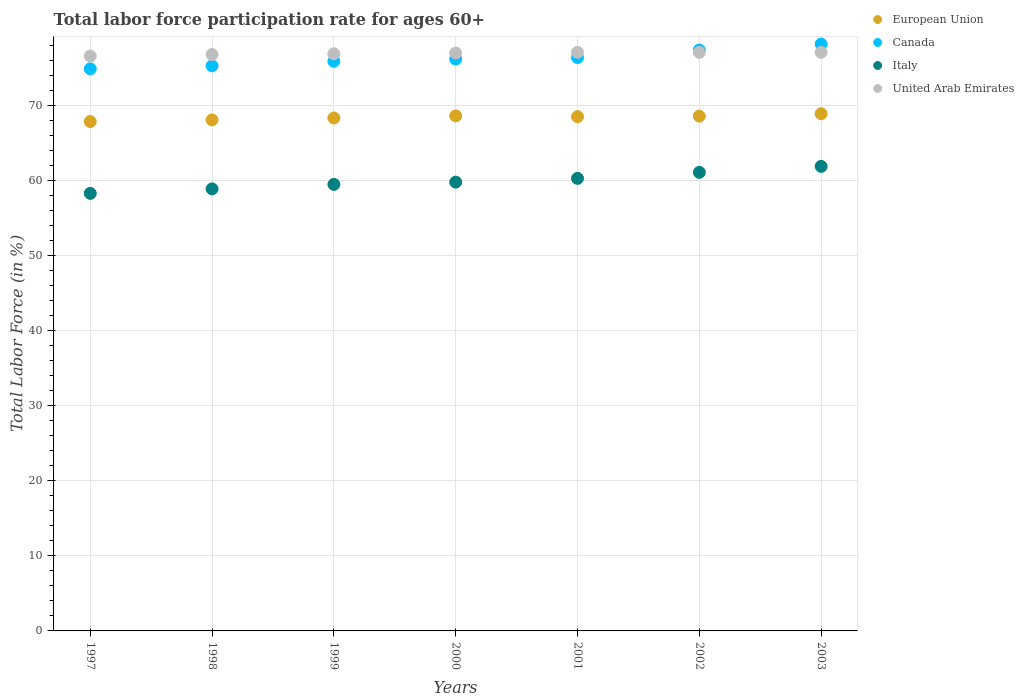Is the number of dotlines equal to the number of legend labels?
Your answer should be very brief. Yes. What is the labor force participation rate in Italy in 2001?
Make the answer very short. 60.3. Across all years, what is the maximum labor force participation rate in United Arab Emirates?
Your response must be concise. 77.1. Across all years, what is the minimum labor force participation rate in European Union?
Offer a terse response. 67.87. In which year was the labor force participation rate in Canada maximum?
Your answer should be very brief. 2003. In which year was the labor force participation rate in United Arab Emirates minimum?
Make the answer very short. 1997. What is the total labor force participation rate in Italy in the graph?
Ensure brevity in your answer.  419.8. What is the difference between the labor force participation rate in Canada in 2002 and that in 2003?
Offer a very short reply. -0.8. What is the difference between the labor force participation rate in Italy in 1999 and the labor force participation rate in European Union in 2001?
Offer a terse response. -9.02. What is the average labor force participation rate in European Union per year?
Your answer should be very brief. 68.42. In the year 2003, what is the difference between the labor force participation rate in European Union and labor force participation rate in Italy?
Offer a terse response. 7.01. In how many years, is the labor force participation rate in United Arab Emirates greater than 40 %?
Offer a very short reply. 7. What is the ratio of the labor force participation rate in United Arab Emirates in 1998 to that in 2001?
Provide a short and direct response. 1. Is the difference between the labor force participation rate in European Union in 2000 and 2003 greater than the difference between the labor force participation rate in Italy in 2000 and 2003?
Provide a short and direct response. Yes. What is the difference between the highest and the second highest labor force participation rate in United Arab Emirates?
Offer a very short reply. 0. What is the difference between the highest and the lowest labor force participation rate in European Union?
Keep it short and to the point. 1.04. Is it the case that in every year, the sum of the labor force participation rate in Italy and labor force participation rate in United Arab Emirates  is greater than the labor force participation rate in Canada?
Your response must be concise. Yes. Is the labor force participation rate in United Arab Emirates strictly greater than the labor force participation rate in Italy over the years?
Ensure brevity in your answer.  Yes. Is the labor force participation rate in Italy strictly less than the labor force participation rate in European Union over the years?
Provide a succinct answer. Yes. How many years are there in the graph?
Your answer should be compact. 7. What is the difference between two consecutive major ticks on the Y-axis?
Your answer should be very brief. 10. Are the values on the major ticks of Y-axis written in scientific E-notation?
Offer a very short reply. No. How are the legend labels stacked?
Provide a succinct answer. Vertical. What is the title of the graph?
Give a very brief answer. Total labor force participation rate for ages 60+. What is the Total Labor Force (in %) in European Union in 1997?
Your answer should be very brief. 67.87. What is the Total Labor Force (in %) in Canada in 1997?
Give a very brief answer. 74.9. What is the Total Labor Force (in %) of Italy in 1997?
Your answer should be compact. 58.3. What is the Total Labor Force (in %) in United Arab Emirates in 1997?
Provide a short and direct response. 76.6. What is the Total Labor Force (in %) of European Union in 1998?
Your answer should be very brief. 68.09. What is the Total Labor Force (in %) of Canada in 1998?
Your answer should be very brief. 75.3. What is the Total Labor Force (in %) of Italy in 1998?
Your response must be concise. 58.9. What is the Total Labor Force (in %) in United Arab Emirates in 1998?
Offer a very short reply. 76.8. What is the Total Labor Force (in %) in European Union in 1999?
Keep it short and to the point. 68.34. What is the Total Labor Force (in %) in Canada in 1999?
Give a very brief answer. 75.9. What is the Total Labor Force (in %) of Italy in 1999?
Your response must be concise. 59.5. What is the Total Labor Force (in %) in United Arab Emirates in 1999?
Ensure brevity in your answer.  76.9. What is the Total Labor Force (in %) in European Union in 2000?
Provide a succinct answer. 68.63. What is the Total Labor Force (in %) of Canada in 2000?
Offer a terse response. 76.2. What is the Total Labor Force (in %) in Italy in 2000?
Provide a short and direct response. 59.8. What is the Total Labor Force (in %) of European Union in 2001?
Ensure brevity in your answer.  68.52. What is the Total Labor Force (in %) in Canada in 2001?
Offer a very short reply. 76.4. What is the Total Labor Force (in %) in Italy in 2001?
Offer a terse response. 60.3. What is the Total Labor Force (in %) of United Arab Emirates in 2001?
Your response must be concise. 77.1. What is the Total Labor Force (in %) of European Union in 2002?
Ensure brevity in your answer.  68.59. What is the Total Labor Force (in %) of Canada in 2002?
Your response must be concise. 77.4. What is the Total Labor Force (in %) in Italy in 2002?
Give a very brief answer. 61.1. What is the Total Labor Force (in %) in United Arab Emirates in 2002?
Your answer should be very brief. 77.1. What is the Total Labor Force (in %) in European Union in 2003?
Make the answer very short. 68.91. What is the Total Labor Force (in %) in Canada in 2003?
Your response must be concise. 78.2. What is the Total Labor Force (in %) in Italy in 2003?
Give a very brief answer. 61.9. What is the Total Labor Force (in %) in United Arab Emirates in 2003?
Provide a short and direct response. 77.1. Across all years, what is the maximum Total Labor Force (in %) of European Union?
Your response must be concise. 68.91. Across all years, what is the maximum Total Labor Force (in %) of Canada?
Offer a terse response. 78.2. Across all years, what is the maximum Total Labor Force (in %) of Italy?
Provide a short and direct response. 61.9. Across all years, what is the maximum Total Labor Force (in %) of United Arab Emirates?
Your answer should be very brief. 77.1. Across all years, what is the minimum Total Labor Force (in %) in European Union?
Offer a terse response. 67.87. Across all years, what is the minimum Total Labor Force (in %) of Canada?
Your answer should be compact. 74.9. Across all years, what is the minimum Total Labor Force (in %) of Italy?
Offer a very short reply. 58.3. Across all years, what is the minimum Total Labor Force (in %) of United Arab Emirates?
Make the answer very short. 76.6. What is the total Total Labor Force (in %) of European Union in the graph?
Offer a very short reply. 478.96. What is the total Total Labor Force (in %) of Canada in the graph?
Provide a short and direct response. 534.3. What is the total Total Labor Force (in %) in Italy in the graph?
Make the answer very short. 419.8. What is the total Total Labor Force (in %) in United Arab Emirates in the graph?
Provide a succinct answer. 538.6. What is the difference between the Total Labor Force (in %) in European Union in 1997 and that in 1998?
Make the answer very short. -0.22. What is the difference between the Total Labor Force (in %) of Canada in 1997 and that in 1998?
Keep it short and to the point. -0.4. What is the difference between the Total Labor Force (in %) of Italy in 1997 and that in 1998?
Your response must be concise. -0.6. What is the difference between the Total Labor Force (in %) in United Arab Emirates in 1997 and that in 1998?
Your answer should be compact. -0.2. What is the difference between the Total Labor Force (in %) in European Union in 1997 and that in 1999?
Give a very brief answer. -0.47. What is the difference between the Total Labor Force (in %) in Canada in 1997 and that in 1999?
Make the answer very short. -1. What is the difference between the Total Labor Force (in %) of European Union in 1997 and that in 2000?
Offer a terse response. -0.76. What is the difference between the Total Labor Force (in %) in Italy in 1997 and that in 2000?
Keep it short and to the point. -1.5. What is the difference between the Total Labor Force (in %) in European Union in 1997 and that in 2001?
Your response must be concise. -0.65. What is the difference between the Total Labor Force (in %) of Canada in 1997 and that in 2001?
Offer a terse response. -1.5. What is the difference between the Total Labor Force (in %) in Italy in 1997 and that in 2001?
Keep it short and to the point. -2. What is the difference between the Total Labor Force (in %) in European Union in 1997 and that in 2002?
Your answer should be compact. -0.72. What is the difference between the Total Labor Force (in %) in Canada in 1997 and that in 2002?
Offer a terse response. -2.5. What is the difference between the Total Labor Force (in %) in Italy in 1997 and that in 2002?
Your response must be concise. -2.8. What is the difference between the Total Labor Force (in %) of United Arab Emirates in 1997 and that in 2002?
Ensure brevity in your answer.  -0.5. What is the difference between the Total Labor Force (in %) in European Union in 1997 and that in 2003?
Your answer should be very brief. -1.04. What is the difference between the Total Labor Force (in %) of Italy in 1997 and that in 2003?
Give a very brief answer. -3.6. What is the difference between the Total Labor Force (in %) in European Union in 1998 and that in 1999?
Your answer should be very brief. -0.25. What is the difference between the Total Labor Force (in %) of Canada in 1998 and that in 1999?
Offer a very short reply. -0.6. What is the difference between the Total Labor Force (in %) of Italy in 1998 and that in 1999?
Give a very brief answer. -0.6. What is the difference between the Total Labor Force (in %) of European Union in 1998 and that in 2000?
Your answer should be very brief. -0.54. What is the difference between the Total Labor Force (in %) in Italy in 1998 and that in 2000?
Provide a short and direct response. -0.9. What is the difference between the Total Labor Force (in %) of United Arab Emirates in 1998 and that in 2000?
Your response must be concise. -0.2. What is the difference between the Total Labor Force (in %) in European Union in 1998 and that in 2001?
Provide a short and direct response. -0.43. What is the difference between the Total Labor Force (in %) in United Arab Emirates in 1998 and that in 2001?
Provide a short and direct response. -0.3. What is the difference between the Total Labor Force (in %) of European Union in 1998 and that in 2002?
Your response must be concise. -0.5. What is the difference between the Total Labor Force (in %) of Canada in 1998 and that in 2002?
Ensure brevity in your answer.  -2.1. What is the difference between the Total Labor Force (in %) of United Arab Emirates in 1998 and that in 2002?
Your answer should be very brief. -0.3. What is the difference between the Total Labor Force (in %) of European Union in 1998 and that in 2003?
Provide a succinct answer. -0.82. What is the difference between the Total Labor Force (in %) in Canada in 1998 and that in 2003?
Ensure brevity in your answer.  -2.9. What is the difference between the Total Labor Force (in %) of European Union in 1999 and that in 2000?
Your answer should be compact. -0.28. What is the difference between the Total Labor Force (in %) in United Arab Emirates in 1999 and that in 2000?
Your answer should be very brief. -0.1. What is the difference between the Total Labor Force (in %) in European Union in 1999 and that in 2001?
Offer a terse response. -0.18. What is the difference between the Total Labor Force (in %) in United Arab Emirates in 1999 and that in 2001?
Provide a succinct answer. -0.2. What is the difference between the Total Labor Force (in %) in European Union in 1999 and that in 2002?
Offer a terse response. -0.24. What is the difference between the Total Labor Force (in %) of Canada in 1999 and that in 2002?
Ensure brevity in your answer.  -1.5. What is the difference between the Total Labor Force (in %) of Italy in 1999 and that in 2002?
Your response must be concise. -1.6. What is the difference between the Total Labor Force (in %) in European Union in 1999 and that in 2003?
Offer a very short reply. -0.57. What is the difference between the Total Labor Force (in %) of European Union in 2000 and that in 2001?
Offer a very short reply. 0.11. What is the difference between the Total Labor Force (in %) of Italy in 2000 and that in 2001?
Your answer should be compact. -0.5. What is the difference between the Total Labor Force (in %) of European Union in 2000 and that in 2002?
Your answer should be very brief. 0.04. What is the difference between the Total Labor Force (in %) of Canada in 2000 and that in 2002?
Keep it short and to the point. -1.2. What is the difference between the Total Labor Force (in %) of Italy in 2000 and that in 2002?
Provide a short and direct response. -1.3. What is the difference between the Total Labor Force (in %) in United Arab Emirates in 2000 and that in 2002?
Offer a terse response. -0.1. What is the difference between the Total Labor Force (in %) of European Union in 2000 and that in 2003?
Keep it short and to the point. -0.28. What is the difference between the Total Labor Force (in %) of Canada in 2000 and that in 2003?
Make the answer very short. -2. What is the difference between the Total Labor Force (in %) in United Arab Emirates in 2000 and that in 2003?
Provide a succinct answer. -0.1. What is the difference between the Total Labor Force (in %) in European Union in 2001 and that in 2002?
Your answer should be compact. -0.07. What is the difference between the Total Labor Force (in %) of Canada in 2001 and that in 2002?
Give a very brief answer. -1. What is the difference between the Total Labor Force (in %) of United Arab Emirates in 2001 and that in 2002?
Make the answer very short. 0. What is the difference between the Total Labor Force (in %) in European Union in 2001 and that in 2003?
Offer a very short reply. -0.39. What is the difference between the Total Labor Force (in %) in Canada in 2001 and that in 2003?
Provide a short and direct response. -1.8. What is the difference between the Total Labor Force (in %) of Italy in 2001 and that in 2003?
Ensure brevity in your answer.  -1.6. What is the difference between the Total Labor Force (in %) in European Union in 2002 and that in 2003?
Your answer should be compact. -0.32. What is the difference between the Total Labor Force (in %) of Canada in 2002 and that in 2003?
Offer a very short reply. -0.8. What is the difference between the Total Labor Force (in %) of Italy in 2002 and that in 2003?
Offer a very short reply. -0.8. What is the difference between the Total Labor Force (in %) in United Arab Emirates in 2002 and that in 2003?
Ensure brevity in your answer.  0. What is the difference between the Total Labor Force (in %) in European Union in 1997 and the Total Labor Force (in %) in Canada in 1998?
Your response must be concise. -7.43. What is the difference between the Total Labor Force (in %) in European Union in 1997 and the Total Labor Force (in %) in Italy in 1998?
Ensure brevity in your answer.  8.97. What is the difference between the Total Labor Force (in %) of European Union in 1997 and the Total Labor Force (in %) of United Arab Emirates in 1998?
Your answer should be very brief. -8.93. What is the difference between the Total Labor Force (in %) of Canada in 1997 and the Total Labor Force (in %) of Italy in 1998?
Offer a very short reply. 16. What is the difference between the Total Labor Force (in %) in Canada in 1997 and the Total Labor Force (in %) in United Arab Emirates in 1998?
Offer a very short reply. -1.9. What is the difference between the Total Labor Force (in %) in Italy in 1997 and the Total Labor Force (in %) in United Arab Emirates in 1998?
Offer a terse response. -18.5. What is the difference between the Total Labor Force (in %) in European Union in 1997 and the Total Labor Force (in %) in Canada in 1999?
Give a very brief answer. -8.03. What is the difference between the Total Labor Force (in %) of European Union in 1997 and the Total Labor Force (in %) of Italy in 1999?
Your answer should be very brief. 8.37. What is the difference between the Total Labor Force (in %) in European Union in 1997 and the Total Labor Force (in %) in United Arab Emirates in 1999?
Your response must be concise. -9.03. What is the difference between the Total Labor Force (in %) of Canada in 1997 and the Total Labor Force (in %) of Italy in 1999?
Your answer should be compact. 15.4. What is the difference between the Total Labor Force (in %) in Italy in 1997 and the Total Labor Force (in %) in United Arab Emirates in 1999?
Provide a succinct answer. -18.6. What is the difference between the Total Labor Force (in %) of European Union in 1997 and the Total Labor Force (in %) of Canada in 2000?
Provide a succinct answer. -8.33. What is the difference between the Total Labor Force (in %) of European Union in 1997 and the Total Labor Force (in %) of Italy in 2000?
Make the answer very short. 8.07. What is the difference between the Total Labor Force (in %) of European Union in 1997 and the Total Labor Force (in %) of United Arab Emirates in 2000?
Your answer should be compact. -9.13. What is the difference between the Total Labor Force (in %) of Canada in 1997 and the Total Labor Force (in %) of Italy in 2000?
Make the answer very short. 15.1. What is the difference between the Total Labor Force (in %) of Italy in 1997 and the Total Labor Force (in %) of United Arab Emirates in 2000?
Your response must be concise. -18.7. What is the difference between the Total Labor Force (in %) in European Union in 1997 and the Total Labor Force (in %) in Canada in 2001?
Your answer should be compact. -8.53. What is the difference between the Total Labor Force (in %) of European Union in 1997 and the Total Labor Force (in %) of Italy in 2001?
Your answer should be compact. 7.57. What is the difference between the Total Labor Force (in %) of European Union in 1997 and the Total Labor Force (in %) of United Arab Emirates in 2001?
Your answer should be very brief. -9.23. What is the difference between the Total Labor Force (in %) of Canada in 1997 and the Total Labor Force (in %) of United Arab Emirates in 2001?
Your response must be concise. -2.2. What is the difference between the Total Labor Force (in %) of Italy in 1997 and the Total Labor Force (in %) of United Arab Emirates in 2001?
Offer a very short reply. -18.8. What is the difference between the Total Labor Force (in %) in European Union in 1997 and the Total Labor Force (in %) in Canada in 2002?
Ensure brevity in your answer.  -9.53. What is the difference between the Total Labor Force (in %) in European Union in 1997 and the Total Labor Force (in %) in Italy in 2002?
Make the answer very short. 6.77. What is the difference between the Total Labor Force (in %) of European Union in 1997 and the Total Labor Force (in %) of United Arab Emirates in 2002?
Your response must be concise. -9.23. What is the difference between the Total Labor Force (in %) of Canada in 1997 and the Total Labor Force (in %) of United Arab Emirates in 2002?
Ensure brevity in your answer.  -2.2. What is the difference between the Total Labor Force (in %) of Italy in 1997 and the Total Labor Force (in %) of United Arab Emirates in 2002?
Your response must be concise. -18.8. What is the difference between the Total Labor Force (in %) in European Union in 1997 and the Total Labor Force (in %) in Canada in 2003?
Provide a succinct answer. -10.33. What is the difference between the Total Labor Force (in %) in European Union in 1997 and the Total Labor Force (in %) in Italy in 2003?
Your answer should be very brief. 5.97. What is the difference between the Total Labor Force (in %) of European Union in 1997 and the Total Labor Force (in %) of United Arab Emirates in 2003?
Ensure brevity in your answer.  -9.23. What is the difference between the Total Labor Force (in %) in Canada in 1997 and the Total Labor Force (in %) in United Arab Emirates in 2003?
Make the answer very short. -2.2. What is the difference between the Total Labor Force (in %) in Italy in 1997 and the Total Labor Force (in %) in United Arab Emirates in 2003?
Your answer should be compact. -18.8. What is the difference between the Total Labor Force (in %) in European Union in 1998 and the Total Labor Force (in %) in Canada in 1999?
Keep it short and to the point. -7.81. What is the difference between the Total Labor Force (in %) in European Union in 1998 and the Total Labor Force (in %) in Italy in 1999?
Make the answer very short. 8.59. What is the difference between the Total Labor Force (in %) of European Union in 1998 and the Total Labor Force (in %) of United Arab Emirates in 1999?
Ensure brevity in your answer.  -8.81. What is the difference between the Total Labor Force (in %) in Canada in 1998 and the Total Labor Force (in %) in Italy in 1999?
Your response must be concise. 15.8. What is the difference between the Total Labor Force (in %) of Italy in 1998 and the Total Labor Force (in %) of United Arab Emirates in 1999?
Your answer should be compact. -18. What is the difference between the Total Labor Force (in %) in European Union in 1998 and the Total Labor Force (in %) in Canada in 2000?
Provide a succinct answer. -8.11. What is the difference between the Total Labor Force (in %) in European Union in 1998 and the Total Labor Force (in %) in Italy in 2000?
Your answer should be very brief. 8.29. What is the difference between the Total Labor Force (in %) in European Union in 1998 and the Total Labor Force (in %) in United Arab Emirates in 2000?
Offer a very short reply. -8.91. What is the difference between the Total Labor Force (in %) of Italy in 1998 and the Total Labor Force (in %) of United Arab Emirates in 2000?
Make the answer very short. -18.1. What is the difference between the Total Labor Force (in %) in European Union in 1998 and the Total Labor Force (in %) in Canada in 2001?
Offer a terse response. -8.31. What is the difference between the Total Labor Force (in %) in European Union in 1998 and the Total Labor Force (in %) in Italy in 2001?
Your response must be concise. 7.79. What is the difference between the Total Labor Force (in %) of European Union in 1998 and the Total Labor Force (in %) of United Arab Emirates in 2001?
Ensure brevity in your answer.  -9.01. What is the difference between the Total Labor Force (in %) of Canada in 1998 and the Total Labor Force (in %) of Italy in 2001?
Your answer should be very brief. 15. What is the difference between the Total Labor Force (in %) in Canada in 1998 and the Total Labor Force (in %) in United Arab Emirates in 2001?
Offer a terse response. -1.8. What is the difference between the Total Labor Force (in %) of Italy in 1998 and the Total Labor Force (in %) of United Arab Emirates in 2001?
Your answer should be very brief. -18.2. What is the difference between the Total Labor Force (in %) in European Union in 1998 and the Total Labor Force (in %) in Canada in 2002?
Your answer should be compact. -9.31. What is the difference between the Total Labor Force (in %) in European Union in 1998 and the Total Labor Force (in %) in Italy in 2002?
Keep it short and to the point. 6.99. What is the difference between the Total Labor Force (in %) in European Union in 1998 and the Total Labor Force (in %) in United Arab Emirates in 2002?
Keep it short and to the point. -9.01. What is the difference between the Total Labor Force (in %) in Canada in 1998 and the Total Labor Force (in %) in United Arab Emirates in 2002?
Ensure brevity in your answer.  -1.8. What is the difference between the Total Labor Force (in %) of Italy in 1998 and the Total Labor Force (in %) of United Arab Emirates in 2002?
Give a very brief answer. -18.2. What is the difference between the Total Labor Force (in %) in European Union in 1998 and the Total Labor Force (in %) in Canada in 2003?
Keep it short and to the point. -10.11. What is the difference between the Total Labor Force (in %) of European Union in 1998 and the Total Labor Force (in %) of Italy in 2003?
Your answer should be very brief. 6.19. What is the difference between the Total Labor Force (in %) of European Union in 1998 and the Total Labor Force (in %) of United Arab Emirates in 2003?
Provide a short and direct response. -9.01. What is the difference between the Total Labor Force (in %) in Italy in 1998 and the Total Labor Force (in %) in United Arab Emirates in 2003?
Your answer should be very brief. -18.2. What is the difference between the Total Labor Force (in %) of European Union in 1999 and the Total Labor Force (in %) of Canada in 2000?
Your answer should be compact. -7.86. What is the difference between the Total Labor Force (in %) of European Union in 1999 and the Total Labor Force (in %) of Italy in 2000?
Ensure brevity in your answer.  8.54. What is the difference between the Total Labor Force (in %) of European Union in 1999 and the Total Labor Force (in %) of United Arab Emirates in 2000?
Keep it short and to the point. -8.66. What is the difference between the Total Labor Force (in %) of Canada in 1999 and the Total Labor Force (in %) of Italy in 2000?
Make the answer very short. 16.1. What is the difference between the Total Labor Force (in %) of Italy in 1999 and the Total Labor Force (in %) of United Arab Emirates in 2000?
Your response must be concise. -17.5. What is the difference between the Total Labor Force (in %) of European Union in 1999 and the Total Labor Force (in %) of Canada in 2001?
Offer a terse response. -8.06. What is the difference between the Total Labor Force (in %) in European Union in 1999 and the Total Labor Force (in %) in Italy in 2001?
Provide a succinct answer. 8.04. What is the difference between the Total Labor Force (in %) of European Union in 1999 and the Total Labor Force (in %) of United Arab Emirates in 2001?
Offer a terse response. -8.76. What is the difference between the Total Labor Force (in %) in Canada in 1999 and the Total Labor Force (in %) in United Arab Emirates in 2001?
Provide a succinct answer. -1.2. What is the difference between the Total Labor Force (in %) in Italy in 1999 and the Total Labor Force (in %) in United Arab Emirates in 2001?
Give a very brief answer. -17.6. What is the difference between the Total Labor Force (in %) of European Union in 1999 and the Total Labor Force (in %) of Canada in 2002?
Your answer should be compact. -9.06. What is the difference between the Total Labor Force (in %) in European Union in 1999 and the Total Labor Force (in %) in Italy in 2002?
Your answer should be very brief. 7.24. What is the difference between the Total Labor Force (in %) of European Union in 1999 and the Total Labor Force (in %) of United Arab Emirates in 2002?
Your response must be concise. -8.76. What is the difference between the Total Labor Force (in %) in Canada in 1999 and the Total Labor Force (in %) in Italy in 2002?
Offer a very short reply. 14.8. What is the difference between the Total Labor Force (in %) in Italy in 1999 and the Total Labor Force (in %) in United Arab Emirates in 2002?
Your response must be concise. -17.6. What is the difference between the Total Labor Force (in %) of European Union in 1999 and the Total Labor Force (in %) of Canada in 2003?
Keep it short and to the point. -9.86. What is the difference between the Total Labor Force (in %) of European Union in 1999 and the Total Labor Force (in %) of Italy in 2003?
Offer a terse response. 6.44. What is the difference between the Total Labor Force (in %) in European Union in 1999 and the Total Labor Force (in %) in United Arab Emirates in 2003?
Your response must be concise. -8.76. What is the difference between the Total Labor Force (in %) of Canada in 1999 and the Total Labor Force (in %) of Italy in 2003?
Your answer should be compact. 14. What is the difference between the Total Labor Force (in %) in Canada in 1999 and the Total Labor Force (in %) in United Arab Emirates in 2003?
Ensure brevity in your answer.  -1.2. What is the difference between the Total Labor Force (in %) in Italy in 1999 and the Total Labor Force (in %) in United Arab Emirates in 2003?
Offer a terse response. -17.6. What is the difference between the Total Labor Force (in %) of European Union in 2000 and the Total Labor Force (in %) of Canada in 2001?
Provide a short and direct response. -7.77. What is the difference between the Total Labor Force (in %) in European Union in 2000 and the Total Labor Force (in %) in Italy in 2001?
Provide a short and direct response. 8.33. What is the difference between the Total Labor Force (in %) of European Union in 2000 and the Total Labor Force (in %) of United Arab Emirates in 2001?
Offer a terse response. -8.47. What is the difference between the Total Labor Force (in %) in Canada in 2000 and the Total Labor Force (in %) in United Arab Emirates in 2001?
Your answer should be very brief. -0.9. What is the difference between the Total Labor Force (in %) in Italy in 2000 and the Total Labor Force (in %) in United Arab Emirates in 2001?
Give a very brief answer. -17.3. What is the difference between the Total Labor Force (in %) of European Union in 2000 and the Total Labor Force (in %) of Canada in 2002?
Your answer should be compact. -8.77. What is the difference between the Total Labor Force (in %) of European Union in 2000 and the Total Labor Force (in %) of Italy in 2002?
Your answer should be very brief. 7.53. What is the difference between the Total Labor Force (in %) in European Union in 2000 and the Total Labor Force (in %) in United Arab Emirates in 2002?
Provide a succinct answer. -8.47. What is the difference between the Total Labor Force (in %) in Canada in 2000 and the Total Labor Force (in %) in United Arab Emirates in 2002?
Your answer should be compact. -0.9. What is the difference between the Total Labor Force (in %) in Italy in 2000 and the Total Labor Force (in %) in United Arab Emirates in 2002?
Provide a short and direct response. -17.3. What is the difference between the Total Labor Force (in %) of European Union in 2000 and the Total Labor Force (in %) of Canada in 2003?
Keep it short and to the point. -9.57. What is the difference between the Total Labor Force (in %) in European Union in 2000 and the Total Labor Force (in %) in Italy in 2003?
Ensure brevity in your answer.  6.73. What is the difference between the Total Labor Force (in %) in European Union in 2000 and the Total Labor Force (in %) in United Arab Emirates in 2003?
Your answer should be very brief. -8.47. What is the difference between the Total Labor Force (in %) of Italy in 2000 and the Total Labor Force (in %) of United Arab Emirates in 2003?
Your response must be concise. -17.3. What is the difference between the Total Labor Force (in %) in European Union in 2001 and the Total Labor Force (in %) in Canada in 2002?
Ensure brevity in your answer.  -8.88. What is the difference between the Total Labor Force (in %) of European Union in 2001 and the Total Labor Force (in %) of Italy in 2002?
Make the answer very short. 7.42. What is the difference between the Total Labor Force (in %) of European Union in 2001 and the Total Labor Force (in %) of United Arab Emirates in 2002?
Provide a short and direct response. -8.58. What is the difference between the Total Labor Force (in %) in Canada in 2001 and the Total Labor Force (in %) in Italy in 2002?
Your response must be concise. 15.3. What is the difference between the Total Labor Force (in %) of Italy in 2001 and the Total Labor Force (in %) of United Arab Emirates in 2002?
Your response must be concise. -16.8. What is the difference between the Total Labor Force (in %) in European Union in 2001 and the Total Labor Force (in %) in Canada in 2003?
Offer a terse response. -9.68. What is the difference between the Total Labor Force (in %) of European Union in 2001 and the Total Labor Force (in %) of Italy in 2003?
Keep it short and to the point. 6.62. What is the difference between the Total Labor Force (in %) in European Union in 2001 and the Total Labor Force (in %) in United Arab Emirates in 2003?
Provide a short and direct response. -8.58. What is the difference between the Total Labor Force (in %) in Canada in 2001 and the Total Labor Force (in %) in Italy in 2003?
Make the answer very short. 14.5. What is the difference between the Total Labor Force (in %) of Canada in 2001 and the Total Labor Force (in %) of United Arab Emirates in 2003?
Your response must be concise. -0.7. What is the difference between the Total Labor Force (in %) in Italy in 2001 and the Total Labor Force (in %) in United Arab Emirates in 2003?
Your response must be concise. -16.8. What is the difference between the Total Labor Force (in %) of European Union in 2002 and the Total Labor Force (in %) of Canada in 2003?
Keep it short and to the point. -9.61. What is the difference between the Total Labor Force (in %) of European Union in 2002 and the Total Labor Force (in %) of Italy in 2003?
Ensure brevity in your answer.  6.69. What is the difference between the Total Labor Force (in %) in European Union in 2002 and the Total Labor Force (in %) in United Arab Emirates in 2003?
Your answer should be compact. -8.51. What is the difference between the Total Labor Force (in %) in Canada in 2002 and the Total Labor Force (in %) in United Arab Emirates in 2003?
Offer a very short reply. 0.3. What is the average Total Labor Force (in %) in European Union per year?
Keep it short and to the point. 68.42. What is the average Total Labor Force (in %) of Canada per year?
Keep it short and to the point. 76.33. What is the average Total Labor Force (in %) in Italy per year?
Your answer should be very brief. 59.97. What is the average Total Labor Force (in %) of United Arab Emirates per year?
Your answer should be compact. 76.94. In the year 1997, what is the difference between the Total Labor Force (in %) of European Union and Total Labor Force (in %) of Canada?
Your response must be concise. -7.03. In the year 1997, what is the difference between the Total Labor Force (in %) of European Union and Total Labor Force (in %) of Italy?
Give a very brief answer. 9.57. In the year 1997, what is the difference between the Total Labor Force (in %) in European Union and Total Labor Force (in %) in United Arab Emirates?
Provide a succinct answer. -8.73. In the year 1997, what is the difference between the Total Labor Force (in %) in Canada and Total Labor Force (in %) in United Arab Emirates?
Offer a terse response. -1.7. In the year 1997, what is the difference between the Total Labor Force (in %) in Italy and Total Labor Force (in %) in United Arab Emirates?
Offer a terse response. -18.3. In the year 1998, what is the difference between the Total Labor Force (in %) of European Union and Total Labor Force (in %) of Canada?
Your answer should be very brief. -7.21. In the year 1998, what is the difference between the Total Labor Force (in %) of European Union and Total Labor Force (in %) of Italy?
Give a very brief answer. 9.19. In the year 1998, what is the difference between the Total Labor Force (in %) of European Union and Total Labor Force (in %) of United Arab Emirates?
Provide a short and direct response. -8.71. In the year 1998, what is the difference between the Total Labor Force (in %) of Canada and Total Labor Force (in %) of Italy?
Make the answer very short. 16.4. In the year 1998, what is the difference between the Total Labor Force (in %) of Canada and Total Labor Force (in %) of United Arab Emirates?
Your answer should be very brief. -1.5. In the year 1998, what is the difference between the Total Labor Force (in %) in Italy and Total Labor Force (in %) in United Arab Emirates?
Your answer should be compact. -17.9. In the year 1999, what is the difference between the Total Labor Force (in %) in European Union and Total Labor Force (in %) in Canada?
Your response must be concise. -7.56. In the year 1999, what is the difference between the Total Labor Force (in %) of European Union and Total Labor Force (in %) of Italy?
Your response must be concise. 8.84. In the year 1999, what is the difference between the Total Labor Force (in %) in European Union and Total Labor Force (in %) in United Arab Emirates?
Ensure brevity in your answer.  -8.56. In the year 1999, what is the difference between the Total Labor Force (in %) in Canada and Total Labor Force (in %) in Italy?
Offer a very short reply. 16.4. In the year 1999, what is the difference between the Total Labor Force (in %) in Italy and Total Labor Force (in %) in United Arab Emirates?
Offer a terse response. -17.4. In the year 2000, what is the difference between the Total Labor Force (in %) of European Union and Total Labor Force (in %) of Canada?
Offer a very short reply. -7.57. In the year 2000, what is the difference between the Total Labor Force (in %) in European Union and Total Labor Force (in %) in Italy?
Provide a succinct answer. 8.83. In the year 2000, what is the difference between the Total Labor Force (in %) of European Union and Total Labor Force (in %) of United Arab Emirates?
Ensure brevity in your answer.  -8.37. In the year 2000, what is the difference between the Total Labor Force (in %) in Italy and Total Labor Force (in %) in United Arab Emirates?
Offer a terse response. -17.2. In the year 2001, what is the difference between the Total Labor Force (in %) in European Union and Total Labor Force (in %) in Canada?
Your response must be concise. -7.88. In the year 2001, what is the difference between the Total Labor Force (in %) in European Union and Total Labor Force (in %) in Italy?
Your answer should be compact. 8.22. In the year 2001, what is the difference between the Total Labor Force (in %) of European Union and Total Labor Force (in %) of United Arab Emirates?
Ensure brevity in your answer.  -8.58. In the year 2001, what is the difference between the Total Labor Force (in %) in Canada and Total Labor Force (in %) in United Arab Emirates?
Make the answer very short. -0.7. In the year 2001, what is the difference between the Total Labor Force (in %) in Italy and Total Labor Force (in %) in United Arab Emirates?
Your response must be concise. -16.8. In the year 2002, what is the difference between the Total Labor Force (in %) in European Union and Total Labor Force (in %) in Canada?
Make the answer very short. -8.81. In the year 2002, what is the difference between the Total Labor Force (in %) in European Union and Total Labor Force (in %) in Italy?
Offer a terse response. 7.49. In the year 2002, what is the difference between the Total Labor Force (in %) of European Union and Total Labor Force (in %) of United Arab Emirates?
Provide a succinct answer. -8.51. In the year 2002, what is the difference between the Total Labor Force (in %) in Canada and Total Labor Force (in %) in United Arab Emirates?
Ensure brevity in your answer.  0.3. In the year 2003, what is the difference between the Total Labor Force (in %) of European Union and Total Labor Force (in %) of Canada?
Provide a short and direct response. -9.29. In the year 2003, what is the difference between the Total Labor Force (in %) in European Union and Total Labor Force (in %) in Italy?
Provide a succinct answer. 7.01. In the year 2003, what is the difference between the Total Labor Force (in %) of European Union and Total Labor Force (in %) of United Arab Emirates?
Ensure brevity in your answer.  -8.19. In the year 2003, what is the difference between the Total Labor Force (in %) in Canada and Total Labor Force (in %) in United Arab Emirates?
Ensure brevity in your answer.  1.1. In the year 2003, what is the difference between the Total Labor Force (in %) in Italy and Total Labor Force (in %) in United Arab Emirates?
Make the answer very short. -15.2. What is the ratio of the Total Labor Force (in %) of Canada in 1997 to that in 1998?
Your answer should be very brief. 0.99. What is the ratio of the Total Labor Force (in %) in Italy in 1997 to that in 1998?
Your answer should be very brief. 0.99. What is the ratio of the Total Labor Force (in %) in European Union in 1997 to that in 1999?
Provide a short and direct response. 0.99. What is the ratio of the Total Labor Force (in %) in Italy in 1997 to that in 1999?
Keep it short and to the point. 0.98. What is the ratio of the Total Labor Force (in %) in United Arab Emirates in 1997 to that in 1999?
Your answer should be compact. 1. What is the ratio of the Total Labor Force (in %) of European Union in 1997 to that in 2000?
Make the answer very short. 0.99. What is the ratio of the Total Labor Force (in %) in Canada in 1997 to that in 2000?
Ensure brevity in your answer.  0.98. What is the ratio of the Total Labor Force (in %) in Italy in 1997 to that in 2000?
Provide a short and direct response. 0.97. What is the ratio of the Total Labor Force (in %) of Canada in 1997 to that in 2001?
Give a very brief answer. 0.98. What is the ratio of the Total Labor Force (in %) in Italy in 1997 to that in 2001?
Make the answer very short. 0.97. What is the ratio of the Total Labor Force (in %) in Italy in 1997 to that in 2002?
Your response must be concise. 0.95. What is the ratio of the Total Labor Force (in %) in European Union in 1997 to that in 2003?
Your answer should be compact. 0.98. What is the ratio of the Total Labor Force (in %) of Canada in 1997 to that in 2003?
Make the answer very short. 0.96. What is the ratio of the Total Labor Force (in %) in Italy in 1997 to that in 2003?
Offer a very short reply. 0.94. What is the ratio of the Total Labor Force (in %) in United Arab Emirates in 1997 to that in 2003?
Your answer should be very brief. 0.99. What is the ratio of the Total Labor Force (in %) of Canada in 1998 to that in 1999?
Offer a very short reply. 0.99. What is the ratio of the Total Labor Force (in %) of Canada in 1998 to that in 2000?
Offer a very short reply. 0.99. What is the ratio of the Total Labor Force (in %) of Italy in 1998 to that in 2000?
Make the answer very short. 0.98. What is the ratio of the Total Labor Force (in %) in United Arab Emirates in 1998 to that in 2000?
Make the answer very short. 1. What is the ratio of the Total Labor Force (in %) of Canada in 1998 to that in 2001?
Offer a terse response. 0.99. What is the ratio of the Total Labor Force (in %) in Italy in 1998 to that in 2001?
Your answer should be very brief. 0.98. What is the ratio of the Total Labor Force (in %) in European Union in 1998 to that in 2002?
Your answer should be compact. 0.99. What is the ratio of the Total Labor Force (in %) in Canada in 1998 to that in 2002?
Offer a very short reply. 0.97. What is the ratio of the Total Labor Force (in %) in United Arab Emirates in 1998 to that in 2002?
Ensure brevity in your answer.  1. What is the ratio of the Total Labor Force (in %) of Canada in 1998 to that in 2003?
Make the answer very short. 0.96. What is the ratio of the Total Labor Force (in %) of Italy in 1998 to that in 2003?
Your answer should be very brief. 0.95. What is the ratio of the Total Labor Force (in %) of United Arab Emirates in 1998 to that in 2003?
Ensure brevity in your answer.  1. What is the ratio of the Total Labor Force (in %) in European Union in 1999 to that in 2001?
Your answer should be very brief. 1. What is the ratio of the Total Labor Force (in %) in Italy in 1999 to that in 2001?
Keep it short and to the point. 0.99. What is the ratio of the Total Labor Force (in %) of United Arab Emirates in 1999 to that in 2001?
Offer a very short reply. 1. What is the ratio of the Total Labor Force (in %) in Canada in 1999 to that in 2002?
Ensure brevity in your answer.  0.98. What is the ratio of the Total Labor Force (in %) in Italy in 1999 to that in 2002?
Give a very brief answer. 0.97. What is the ratio of the Total Labor Force (in %) in Canada in 1999 to that in 2003?
Your answer should be compact. 0.97. What is the ratio of the Total Labor Force (in %) of Italy in 1999 to that in 2003?
Provide a short and direct response. 0.96. What is the ratio of the Total Labor Force (in %) in European Union in 2000 to that in 2002?
Offer a very short reply. 1. What is the ratio of the Total Labor Force (in %) of Canada in 2000 to that in 2002?
Give a very brief answer. 0.98. What is the ratio of the Total Labor Force (in %) of Italy in 2000 to that in 2002?
Keep it short and to the point. 0.98. What is the ratio of the Total Labor Force (in %) in United Arab Emirates in 2000 to that in 2002?
Ensure brevity in your answer.  1. What is the ratio of the Total Labor Force (in %) of European Union in 2000 to that in 2003?
Keep it short and to the point. 1. What is the ratio of the Total Labor Force (in %) in Canada in 2000 to that in 2003?
Your answer should be compact. 0.97. What is the ratio of the Total Labor Force (in %) of Italy in 2000 to that in 2003?
Your answer should be very brief. 0.97. What is the ratio of the Total Labor Force (in %) in United Arab Emirates in 2000 to that in 2003?
Your response must be concise. 1. What is the ratio of the Total Labor Force (in %) of Canada in 2001 to that in 2002?
Make the answer very short. 0.99. What is the ratio of the Total Labor Force (in %) in Italy in 2001 to that in 2002?
Your response must be concise. 0.99. What is the ratio of the Total Labor Force (in %) of United Arab Emirates in 2001 to that in 2002?
Your response must be concise. 1. What is the ratio of the Total Labor Force (in %) of Canada in 2001 to that in 2003?
Offer a terse response. 0.98. What is the ratio of the Total Labor Force (in %) of Italy in 2001 to that in 2003?
Offer a terse response. 0.97. What is the ratio of the Total Labor Force (in %) of European Union in 2002 to that in 2003?
Make the answer very short. 1. What is the ratio of the Total Labor Force (in %) in Canada in 2002 to that in 2003?
Keep it short and to the point. 0.99. What is the ratio of the Total Labor Force (in %) in Italy in 2002 to that in 2003?
Keep it short and to the point. 0.99. What is the ratio of the Total Labor Force (in %) of United Arab Emirates in 2002 to that in 2003?
Keep it short and to the point. 1. What is the difference between the highest and the second highest Total Labor Force (in %) of European Union?
Provide a succinct answer. 0.28. What is the difference between the highest and the second highest Total Labor Force (in %) in United Arab Emirates?
Give a very brief answer. 0. What is the difference between the highest and the lowest Total Labor Force (in %) in European Union?
Provide a short and direct response. 1.04. What is the difference between the highest and the lowest Total Labor Force (in %) in Canada?
Your response must be concise. 3.3. What is the difference between the highest and the lowest Total Labor Force (in %) of Italy?
Provide a succinct answer. 3.6. What is the difference between the highest and the lowest Total Labor Force (in %) of United Arab Emirates?
Offer a very short reply. 0.5. 